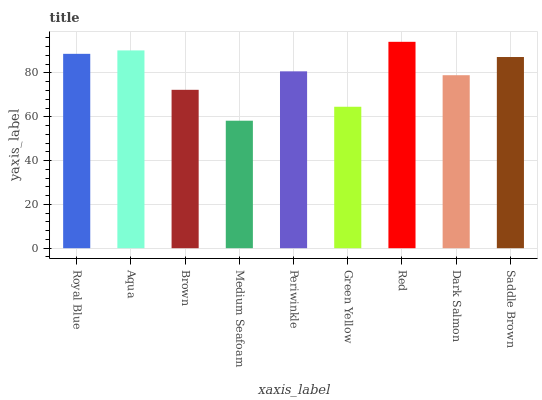Is Medium Seafoam the minimum?
Answer yes or no. Yes. Is Red the maximum?
Answer yes or no. Yes. Is Aqua the minimum?
Answer yes or no. No. Is Aqua the maximum?
Answer yes or no. No. Is Aqua greater than Royal Blue?
Answer yes or no. Yes. Is Royal Blue less than Aqua?
Answer yes or no. Yes. Is Royal Blue greater than Aqua?
Answer yes or no. No. Is Aqua less than Royal Blue?
Answer yes or no. No. Is Periwinkle the high median?
Answer yes or no. Yes. Is Periwinkle the low median?
Answer yes or no. Yes. Is Green Yellow the high median?
Answer yes or no. No. Is Brown the low median?
Answer yes or no. No. 